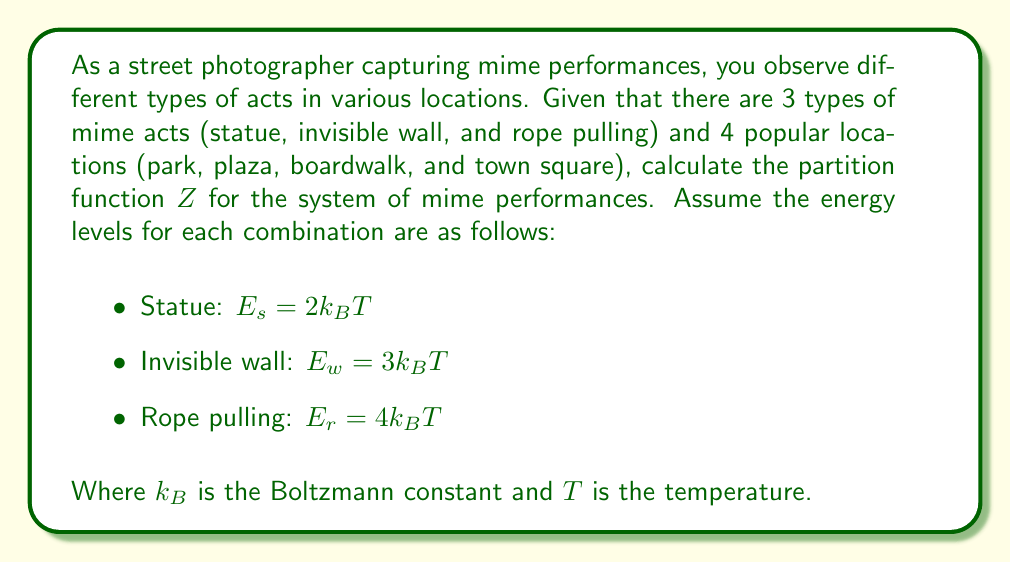What is the answer to this math problem? To calculate the partition function Z, we need to sum over all possible states of the system. In this case, we have 3 types of acts and 4 locations, giving us a total of 12 possible states.

Step 1: Write the general form of the partition function:
$$Z = \sum_i g_i e^{-\beta E_i}$$
Where $g_i$ is the degeneracy of each state, $\beta = \frac{1}{k_BT}$, and $E_i$ is the energy of each state.

Step 2: Calculate the Boltzmann factors for each act:
- Statue: $e^{-\beta E_s} = e^{-2} = 0.1353$
- Invisible wall: $e^{-\beta E_w} = e^{-3} = 0.0498$
- Rope pulling: $e^{-\beta E_r} = e^{-4} = 0.0183$

Step 3: Determine the degeneracy for each act:
Each act can be performed in 4 locations, so $g_i = 4$ for all acts.

Step 4: Calculate the partition function:
$$Z = 4(e^{-2} + e^{-3} + e^{-4})$$
$$Z = 4(0.1353 + 0.0498 + 0.0183)$$
$$Z = 4(0.2034)$$
$$Z = 0.8136$$
Answer: $Z = 0.8136$ 